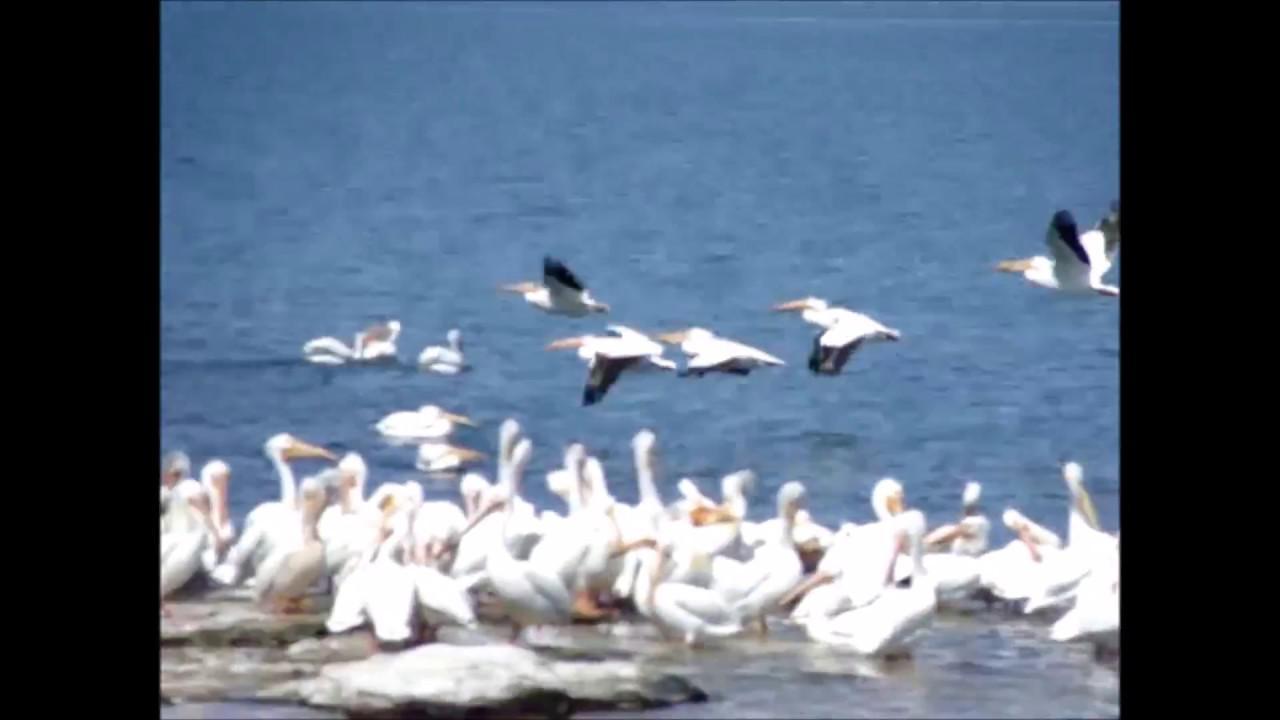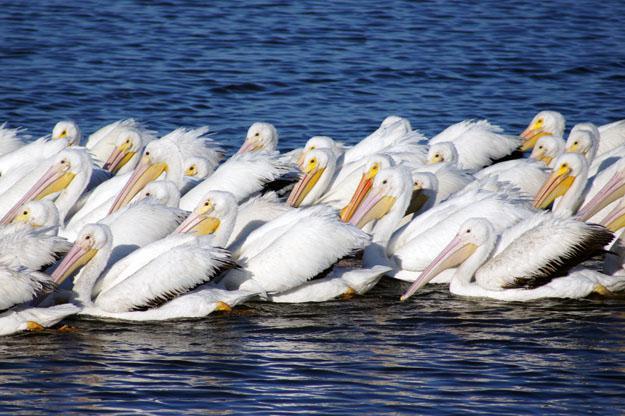The first image is the image on the left, the second image is the image on the right. Evaluate the accuracy of this statement regarding the images: "Multiple birds are in flight in one image.". Is it true? Answer yes or no. Yes. 